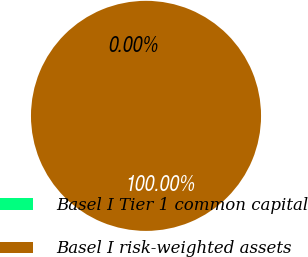Convert chart. <chart><loc_0><loc_0><loc_500><loc_500><pie_chart><fcel>Basel I Tier 1 common capital<fcel>Basel I risk-weighted assets<nl><fcel>0.0%<fcel>100.0%<nl></chart> 